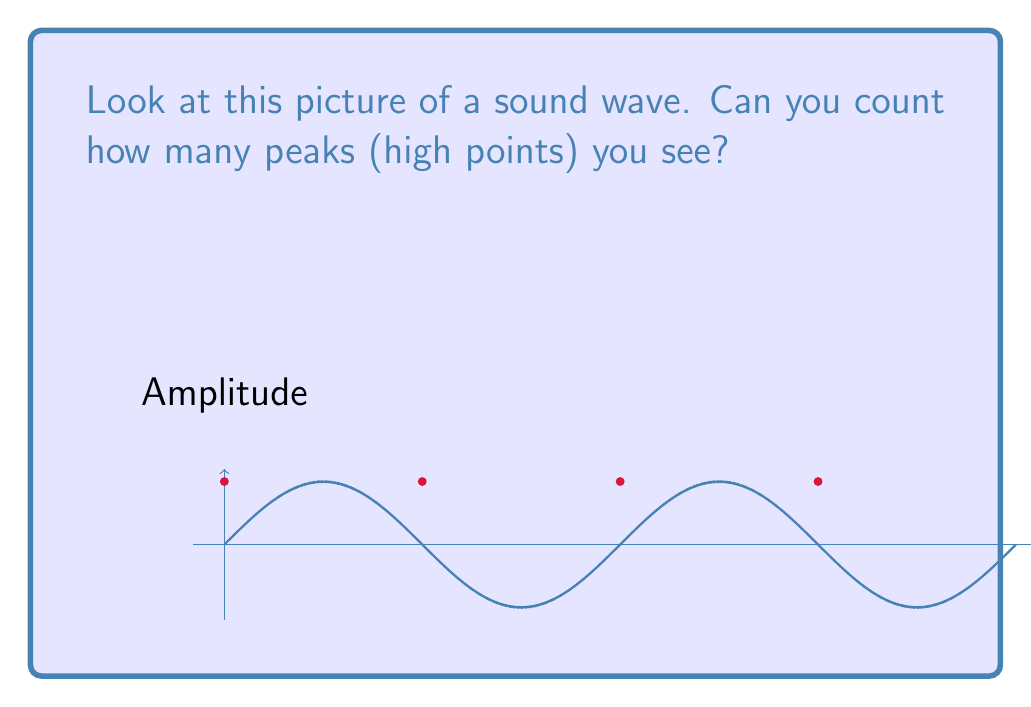Solve this math problem. Let's count the peaks together:

1. Start from the left side of the picture.
2. Look for the highest points of the wave.
3. Count each high point you see:
   - First peak: at the beginning
   - Second peak: in the middle
   - Third peak: near the end
   - Fourth peak: at the very end

We can see 4 red dots marking these high points.

The wave equation for this simple sine wave is:

$$y = A \sin(2\pi ft)$$

Where $A$ is the amplitude (height of the wave), $f$ is the frequency (how often it repeats), and $t$ is time.

In this picture, we see 2 complete cycles, which means 4 peaks in total.
Answer: 4 peaks 